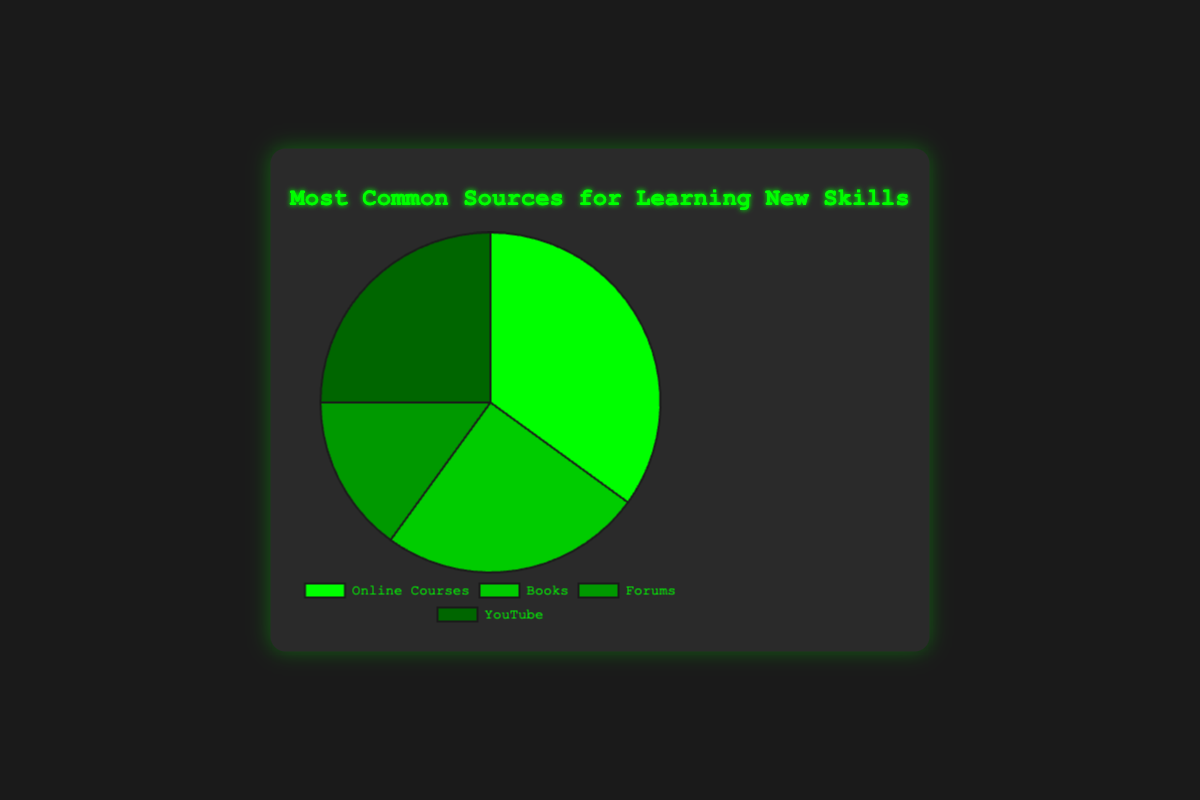What is the most common source for learning new skills? The Online Courses section is the largest slice in the pie chart, indicating it has the highest percentage.
Answer: Online Courses Which sources are equally common for learning new skills? Both Books and YouTube have slices of equal size in the pie chart, each representing 25% of the total.
Answer: Books and YouTube Which source has the smallest percentage for learning new skills? The smallest slice in the pie chart represents the Forums source.
Answer: Forums What is the combined percentage of Books and YouTube as sources for learning new skills? Both Books and YouTube have percentages of 25% each. Adding them gives 25% + 25% = 50%.
Answer: 50% How much more common are Online Courses compared to Forums as sources for learning new skills? Online Courses have a percentage of 35%, while Forums have 15%. The difference is 35% - 15% = 20%.
Answer: 20% Rank the sources from most common to least common for learning new skills. The percentages are: Online Courses (35%), Books (25%), YouTube (25%), and Forums (15%).
Answer: Online Courses, Books & YouTube, Forums If you were to combine Online Courses and Forums, what percentage would they represent? Online Courses have 35% and Forums have 15%, so combined they make 35% + 15% = 50%.
Answer: 50% Which segment is represented by the darkest shade of green in the pie chart? The Forums segment is represented by the darkest shade of green.
Answer: Forums Find the average percentage of Online Courses and Books. The percentages for Online Courses and Books are 35% and 25% respectively. The average is (35% + 25%) / 2 = 30%.
Answer: 30% In terms of size, how does the combined percentage of Online Courses and YouTube compare to the total percentage of Books and Forums? Online Courses (35%) + YouTube (25%) = 60%, while Books (25%) + Forums (15%) = 40%. Thus, 60% is greater than 40%.
Answer: 60% > 40% 